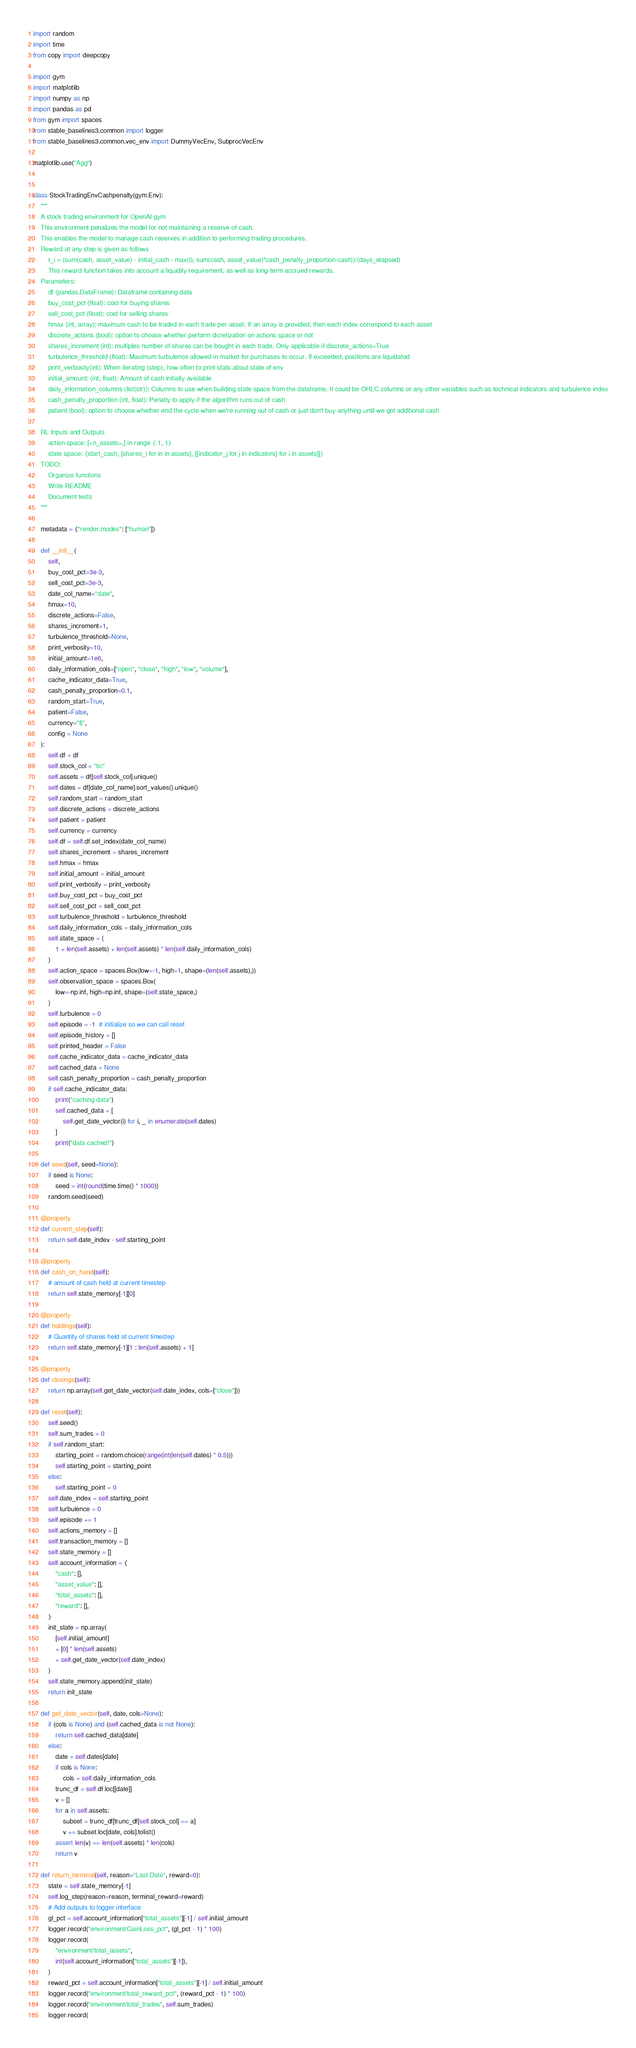<code> <loc_0><loc_0><loc_500><loc_500><_Python_>import random
import time
from copy import deepcopy

import gym
import matplotlib
import numpy as np
import pandas as pd
from gym import spaces
from stable_baselines3.common import logger
from stable_baselines3.common.vec_env import DummyVecEnv, SubprocVecEnv

matplotlib.use("Agg")


class StockTradingEnvCashpenalty(gym.Env):
    """
    A stock trading environment for OpenAI gym
    This environment penalizes the model for not maintaining a reserve of cash.
    This enables the model to manage cash reserves in addition to performing trading procedures.
    Reward at any step is given as follows
        r_i = (sum(cash, asset_value) - initial_cash - max(0, sum(cash, asset_value)*cash_penalty_proportion-cash))/(days_elapsed)
        This reward function takes into account a liquidity requirement, as well as long-term accrued rewards.
    Parameters:
        df (pandas.DataFrame): Dataframe containing data
        buy_cost_pct (float): cost for buying shares
        sell_cost_pct (float): cost for selling shares
        hmax (int, array): maximum cash to be traded in each trade per asset. If an array is provided, then each index correspond to each asset
        discrete_actions (bool): option to choose whether perform dicretization on actions space or not
        shares_increment (int): multiples number of shares can be bought in each trade. Only applicable if discrete_actions=True
        turbulence_threshold (float): Maximum turbulence allowed in market for purchases to occur. If exceeded, positions are liquidated
        print_verbosity(int): When iterating (step), how often to print stats about state of env
        initial_amount: (int, float): Amount of cash initially available
        daily_information_columns (list(str)): Columns to use when building state space from the dataframe. It could be OHLC columns or any other variables such as technical indicators and turbulence index
        cash_penalty_proportion (int, float): Penalty to apply if the algorithm runs out of cash
        patient (bool): option to choose whether end the cycle when we're running out of cash or just don't buy anything until we got additional cash

    RL Inputs and Outputs
        action space: [<n_assets>,] in range {-1, 1}
        state space: {start_cash, [shares_i for in in assets], [[indicator_j for j in indicators] for i in assets]]}
    TODO:
        Organize functions
        Write README
        Document tests
    """

    metadata = {"render.modes": ["human"]}

    def __init__(
        self,
        buy_cost_pct=3e-3,
        sell_cost_pct=3e-3,
        date_col_name="date",
        hmax=10,
        discrete_actions=False,
        shares_increment=1,
        turbulence_threshold=None,
        print_verbosity=10,
        initial_amount=1e6,
        daily_information_cols=["open", "close", "high", "low", "volume"],
        cache_indicator_data=True,
        cash_penalty_proportion=0.1,
        random_start=True,
        patient=False,
        currency="$",
        config = None
    ):
        self.df = df
        self.stock_col = "tic"
        self.assets = df[self.stock_col].unique()
        self.dates = df[date_col_name].sort_values().unique()
        self.random_start = random_start
        self.discrete_actions = discrete_actions
        self.patient = patient
        self.currency = currency
        self.df = self.df.set_index(date_col_name)
        self.shares_increment = shares_increment
        self.hmax = hmax
        self.initial_amount = initial_amount
        self.print_verbosity = print_verbosity
        self.buy_cost_pct = buy_cost_pct
        self.sell_cost_pct = sell_cost_pct
        self.turbulence_threshold = turbulence_threshold
        self.daily_information_cols = daily_information_cols
        self.state_space = (
            1 + len(self.assets) + len(self.assets) * len(self.daily_information_cols)
        )
        self.action_space = spaces.Box(low=-1, high=1, shape=(len(self.assets),))
        self.observation_space = spaces.Box(
            low=-np.inf, high=np.inf, shape=(self.state_space,)
        )
        self.turbulence = 0
        self.episode = -1  # initialize so we can call reset
        self.episode_history = []
        self.printed_header = False
        self.cache_indicator_data = cache_indicator_data
        self.cached_data = None
        self.cash_penalty_proportion = cash_penalty_proportion
        if self.cache_indicator_data:
            print("caching data")
            self.cached_data = [
                self.get_date_vector(i) for i, _ in enumerate(self.dates)
            ]
            print("data cached!")

    def seed(self, seed=None):
        if seed is None:
            seed = int(round(time.time() * 1000))
        random.seed(seed)

    @property
    def current_step(self):
        return self.date_index - self.starting_point

    @property
    def cash_on_hand(self):
        # amount of cash held at current timestep
        return self.state_memory[-1][0]

    @property
    def holdings(self):
        # Quantity of shares held at current timestep
        return self.state_memory[-1][1 : len(self.assets) + 1]

    @property
    def closings(self):
        return np.array(self.get_date_vector(self.date_index, cols=["close"]))

    def reset(self):
        self.seed()
        self.sum_trades = 0
        if self.random_start:
            starting_point = random.choice(range(int(len(self.dates) * 0.5)))
            self.starting_point = starting_point
        else:
            self.starting_point = 0
        self.date_index = self.starting_point
        self.turbulence = 0
        self.episode += 1
        self.actions_memory = []
        self.transaction_memory = []
        self.state_memory = []
        self.account_information = {
            "cash": [],
            "asset_value": [],
            "total_assets": [],
            "reward": [],
        }
        init_state = np.array(
            [self.initial_amount]
            + [0] * len(self.assets)
            + self.get_date_vector(self.date_index)
        )
        self.state_memory.append(init_state)
        return init_state

    def get_date_vector(self, date, cols=None):
        if (cols is None) and (self.cached_data is not None):
            return self.cached_data[date]
        else:
            date = self.dates[date]
            if cols is None:
                cols = self.daily_information_cols
            trunc_df = self.df.loc[[date]]
            v = []
            for a in self.assets:
                subset = trunc_df[trunc_df[self.stock_col] == a]
                v += subset.loc[date, cols].tolist()
            assert len(v) == len(self.assets) * len(cols)
            return v

    def return_terminal(self, reason="Last Date", reward=0):
        state = self.state_memory[-1]
        self.log_step(reason=reason, terminal_reward=reward)
        # Add outputs to logger interface
        gl_pct = self.account_information["total_assets"][-1] / self.initial_amount
        logger.record("environment/GainLoss_pct", (gl_pct - 1) * 100)
        logger.record(
            "environment/total_assets",
            int(self.account_information["total_assets"][-1]),
        )
        reward_pct = self.account_information["total_assets"][-1] / self.initial_amount
        logger.record("environment/total_reward_pct", (reward_pct - 1) * 100)
        logger.record("environment/total_trades", self.sum_trades)
        logger.record(</code> 